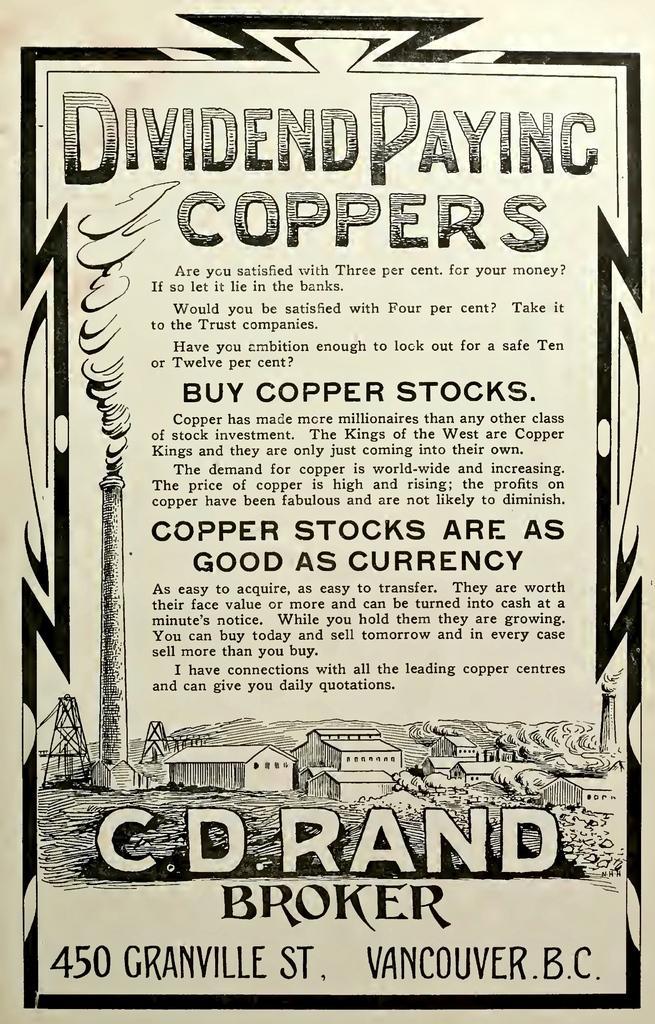Can you describe this image briefly? In this image we can see a poster on which we have some text and some painting. 